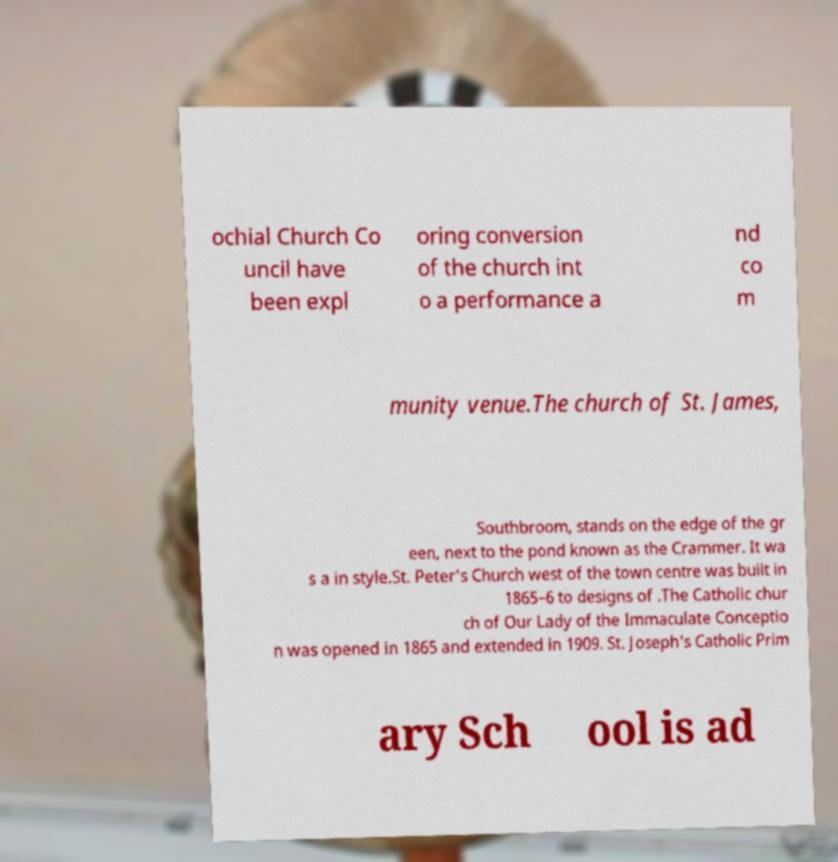Please identify and transcribe the text found in this image. ochial Church Co uncil have been expl oring conversion of the church int o a performance a nd co m munity venue.The church of St. James, Southbroom, stands on the edge of the gr een, next to the pond known as the Crammer. It wa s a in style.St. Peter's Church west of the town centre was built in 1865–6 to designs of .The Catholic chur ch of Our Lady of the Immaculate Conceptio n was opened in 1865 and extended in 1909. St. Joseph's Catholic Prim ary Sch ool is ad 